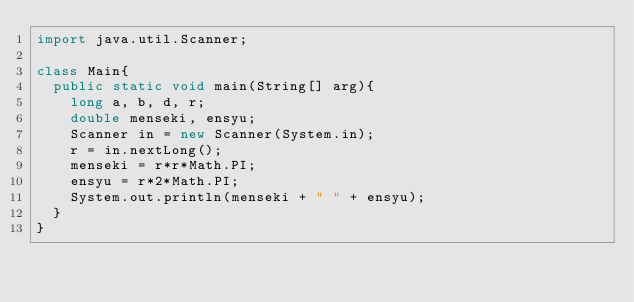Convert code to text. <code><loc_0><loc_0><loc_500><loc_500><_Java_>import java.util.Scanner;

class Main{
  public static void main(String[] arg){
  	long a, b, d, r;
  	double menseki, ensyu;
  	Scanner in = new Scanner(System.in);
  	r = in.nextLong();
  	menseki = r*r*Math.PI;
  	ensyu = r*2*Math.PI;
  	System.out.println(menseki + " " + ensyu);
	}
}</code> 